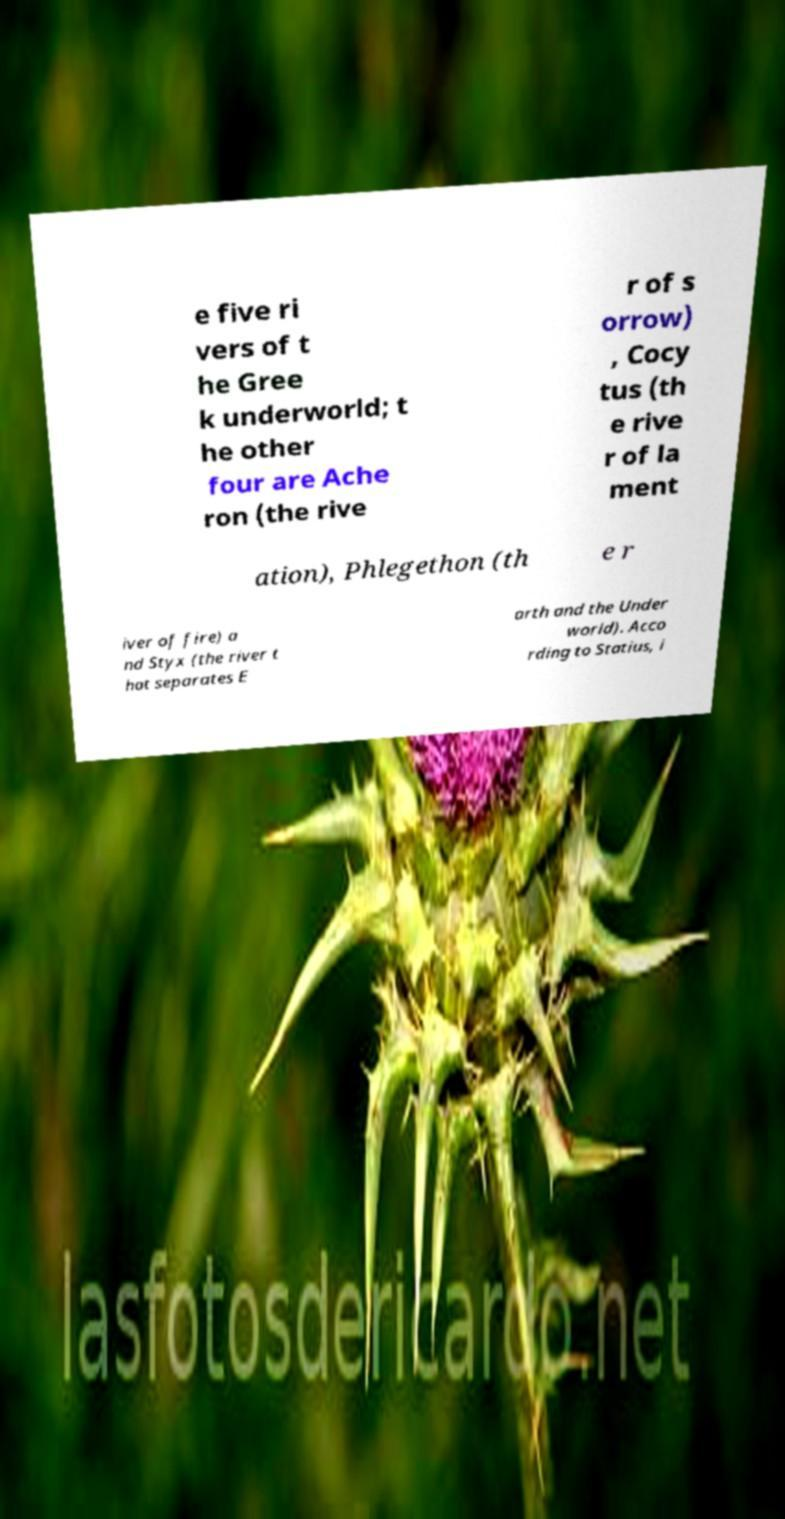Please read and relay the text visible in this image. What does it say? e five ri vers of t he Gree k underworld; t he other four are Ache ron (the rive r of s orrow) , Cocy tus (th e rive r of la ment ation), Phlegethon (th e r iver of fire) a nd Styx (the river t hat separates E arth and the Under world). Acco rding to Statius, i 